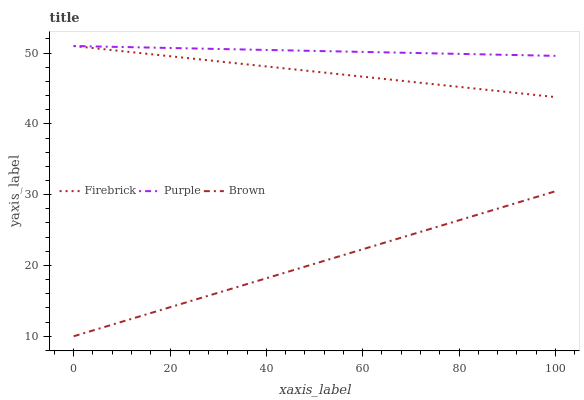Does Brown have the minimum area under the curve?
Answer yes or no. Yes. Does Purple have the maximum area under the curve?
Answer yes or no. Yes. Does Firebrick have the minimum area under the curve?
Answer yes or no. No. Does Firebrick have the maximum area under the curve?
Answer yes or no. No. Is Firebrick the smoothest?
Answer yes or no. Yes. Is Purple the roughest?
Answer yes or no. Yes. Is Brown the smoothest?
Answer yes or no. No. Is Brown the roughest?
Answer yes or no. No. Does Brown have the lowest value?
Answer yes or no. Yes. Does Firebrick have the lowest value?
Answer yes or no. No. Does Firebrick have the highest value?
Answer yes or no. Yes. Does Brown have the highest value?
Answer yes or no. No. Is Brown less than Firebrick?
Answer yes or no. Yes. Is Firebrick greater than Brown?
Answer yes or no. Yes. Does Firebrick intersect Purple?
Answer yes or no. Yes. Is Firebrick less than Purple?
Answer yes or no. No. Is Firebrick greater than Purple?
Answer yes or no. No. Does Brown intersect Firebrick?
Answer yes or no. No. 